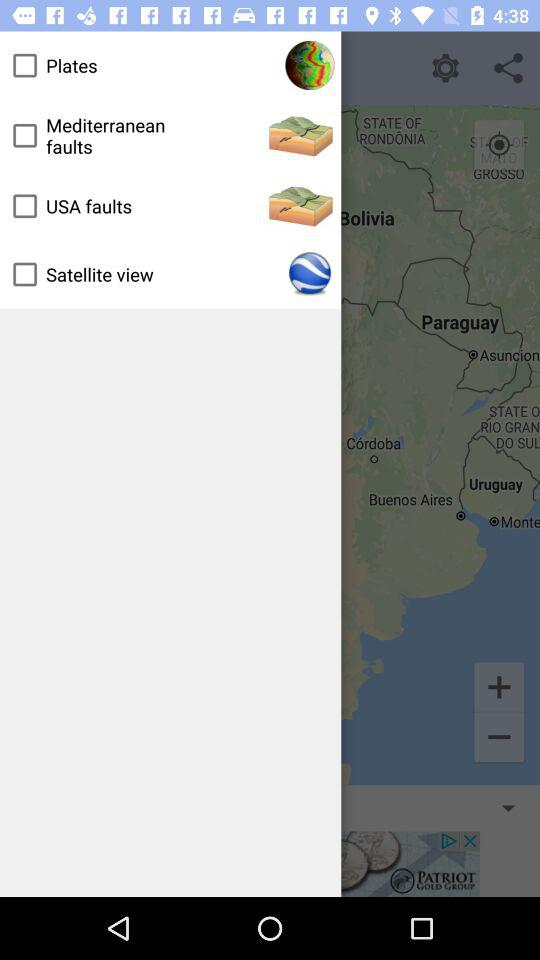What is the status of "USA faults"? The status of "USA faults" is "off". 